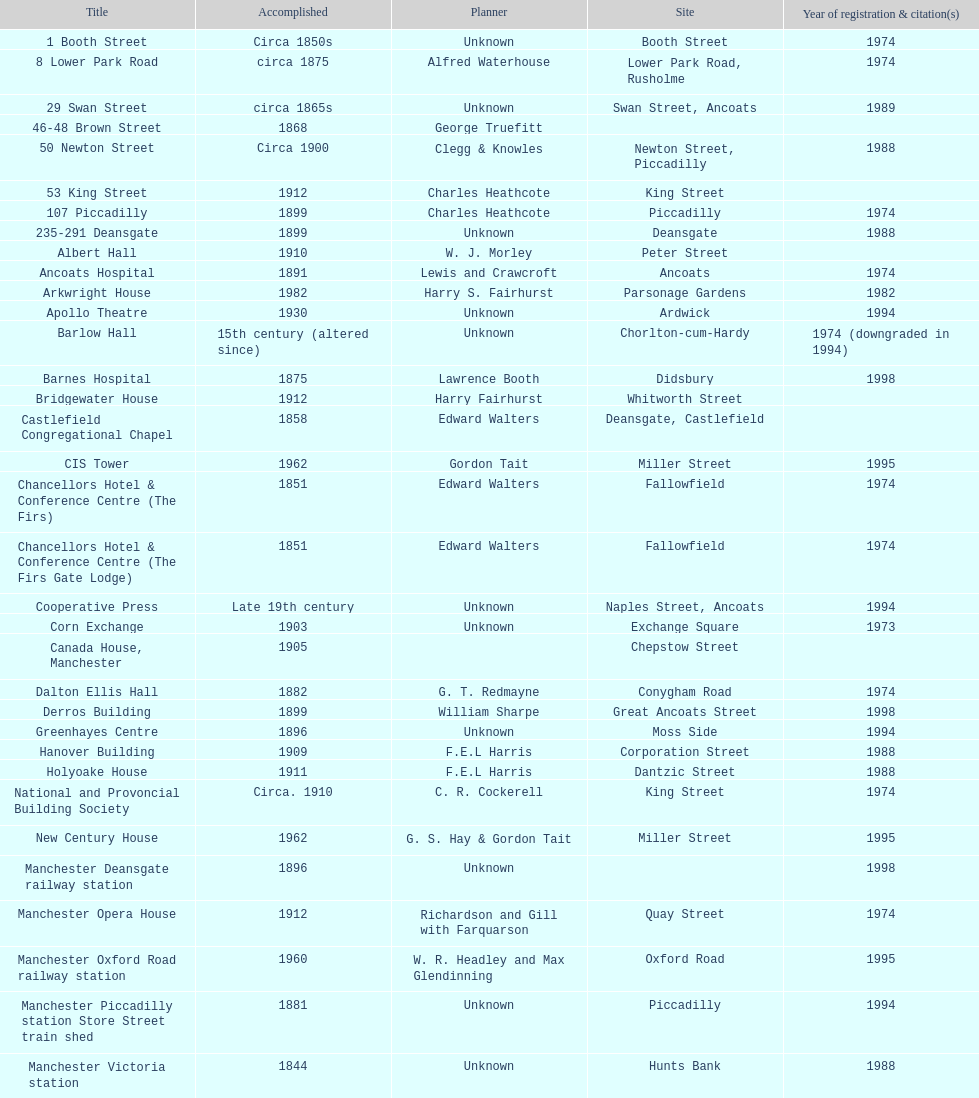In 1974, how many buildings were listed as having the same year? 15. 